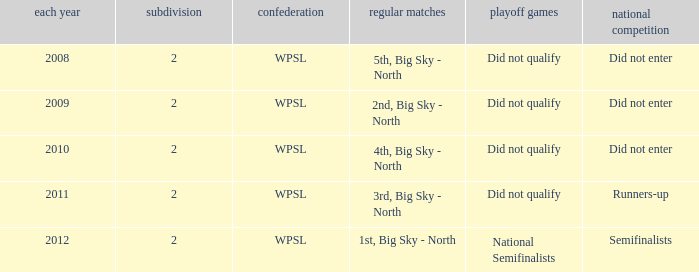What is the lowest division number? 2.0. 